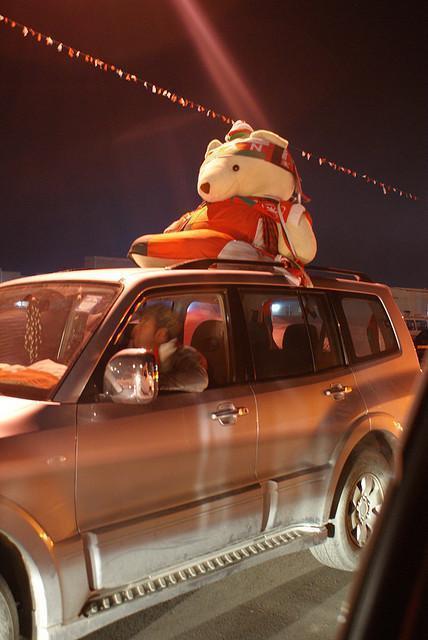What country is the scene located at?
Indicate the correct response and explain using: 'Answer: answer
Rationale: rationale.'
Options: Japan, iran, thailand, china. Answer: japan.
Rationale: There is a south asian person in the car. 